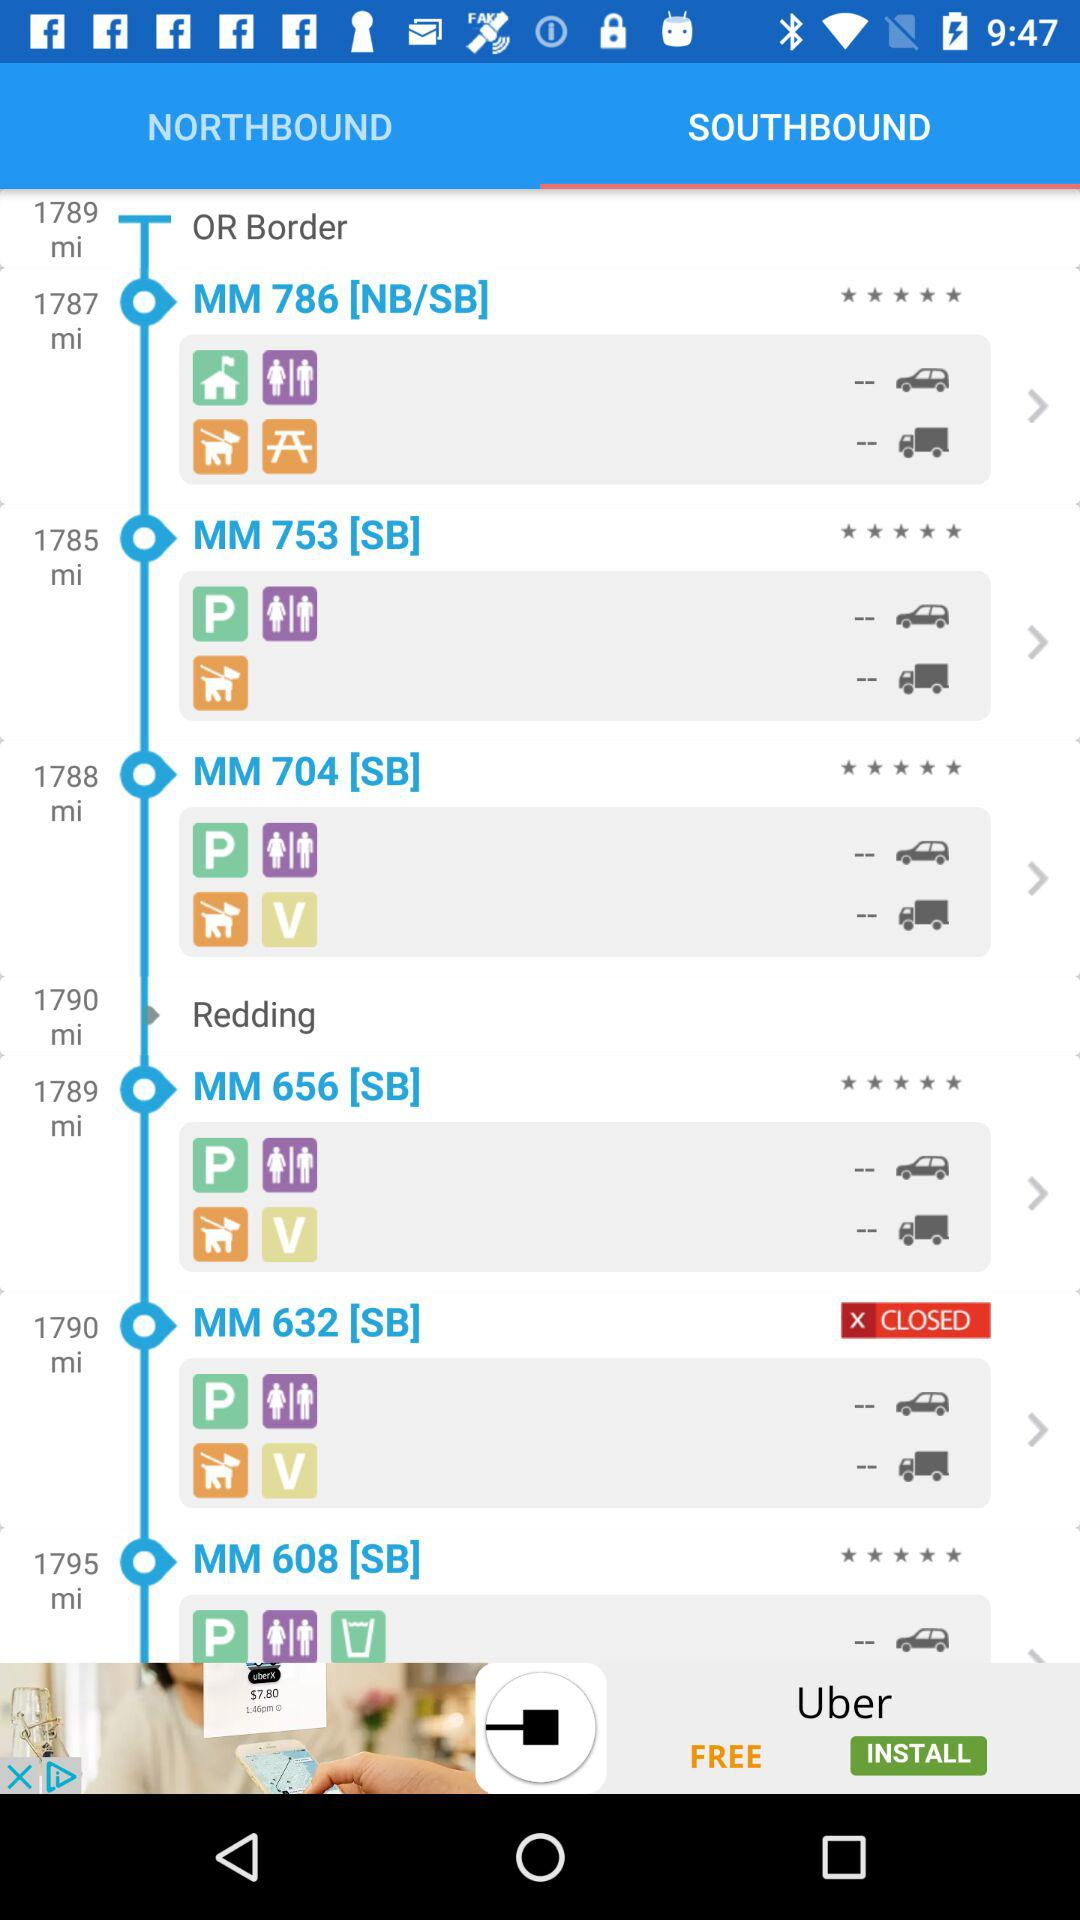What is the distance for MM 704 [SB]? The distance is 1788 miles. 